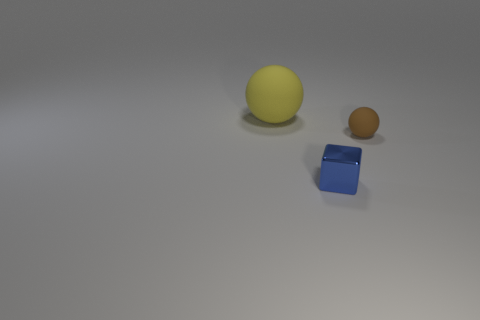Add 1 tiny objects. How many objects exist? 4 Subtract all balls. How many objects are left? 1 Subtract all small shiny cubes. Subtract all tiny blue shiny things. How many objects are left? 1 Add 2 tiny matte spheres. How many tiny matte spheres are left? 3 Add 1 small blocks. How many small blocks exist? 2 Subtract 0 red blocks. How many objects are left? 3 